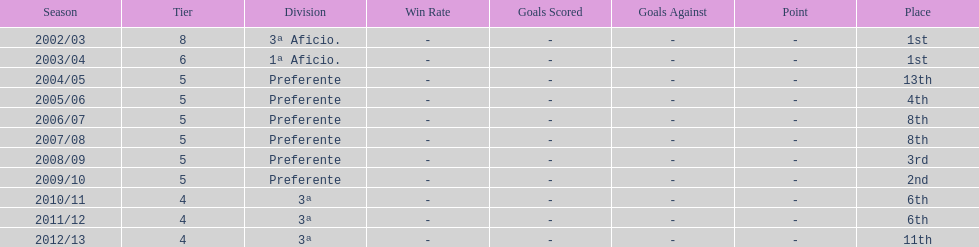In what year did the team achieve the same place as 2010/11? 2011/12. 